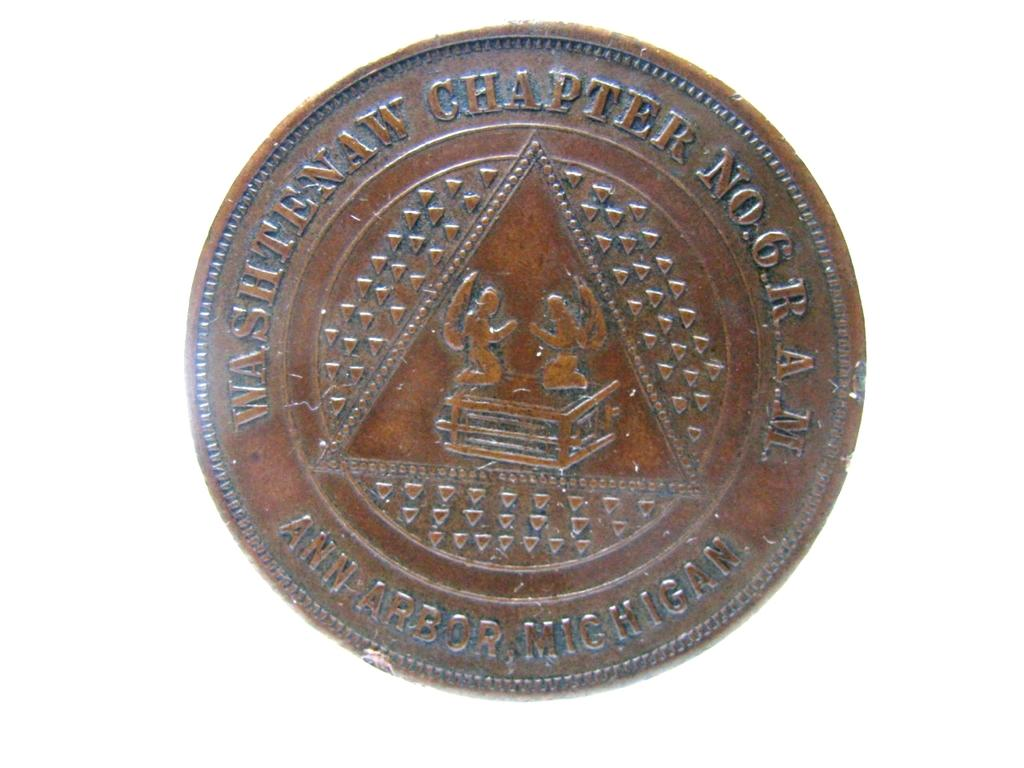What is the main subject of the image? The main subject of the image is a coin. What can be seen on the surface of the coin? There is text on the coin. Can you describe the bridge depicted on the coin? There is no bridge depicted on the coin; the image only shows a coin with text on it. 